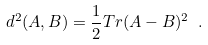Convert formula to latex. <formula><loc_0><loc_0><loc_500><loc_500>d ^ { 2 } ( A , B ) = \frac { 1 } { 2 } T r ( A - B ) ^ { 2 } \ .</formula> 